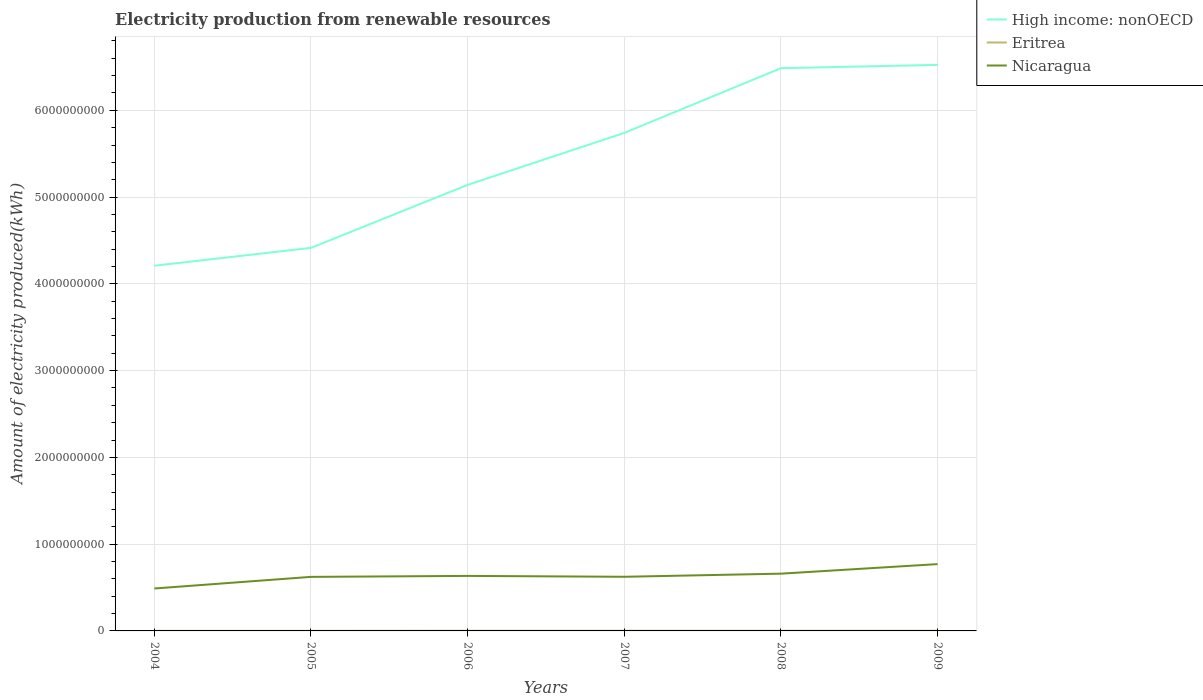How many different coloured lines are there?
Provide a succinct answer. 3. Does the line corresponding to Eritrea intersect with the line corresponding to Nicaragua?
Provide a succinct answer. No. Is the number of lines equal to the number of legend labels?
Your answer should be very brief. Yes. Across all years, what is the maximum amount of electricity produced in Nicaragua?
Offer a terse response. 4.89e+08. In which year was the amount of electricity produced in Eritrea maximum?
Provide a succinct answer. 2004. What is the total amount of electricity produced in Nicaragua in the graph?
Offer a terse response. -3.70e+07. What is the difference between the highest and the second highest amount of electricity produced in Eritrea?
Make the answer very short. 1.00e+06. How many lines are there?
Provide a succinct answer. 3. How many years are there in the graph?
Offer a very short reply. 6. What is the difference between two consecutive major ticks on the Y-axis?
Provide a succinct answer. 1.00e+09. Does the graph contain any zero values?
Make the answer very short. No. How many legend labels are there?
Keep it short and to the point. 3. What is the title of the graph?
Give a very brief answer. Electricity production from renewable resources. Does "Azerbaijan" appear as one of the legend labels in the graph?
Provide a short and direct response. No. What is the label or title of the X-axis?
Your answer should be compact. Years. What is the label or title of the Y-axis?
Ensure brevity in your answer.  Amount of electricity produced(kWh). What is the Amount of electricity produced(kWh) of High income: nonOECD in 2004?
Make the answer very short. 4.21e+09. What is the Amount of electricity produced(kWh) of Nicaragua in 2004?
Give a very brief answer. 4.89e+08. What is the Amount of electricity produced(kWh) of High income: nonOECD in 2005?
Your response must be concise. 4.42e+09. What is the Amount of electricity produced(kWh) of Eritrea in 2005?
Provide a succinct answer. 1.00e+06. What is the Amount of electricity produced(kWh) of Nicaragua in 2005?
Your answer should be very brief. 6.23e+08. What is the Amount of electricity produced(kWh) of High income: nonOECD in 2006?
Keep it short and to the point. 5.14e+09. What is the Amount of electricity produced(kWh) of Eritrea in 2006?
Offer a very short reply. 2.00e+06. What is the Amount of electricity produced(kWh) of Nicaragua in 2006?
Your answer should be compact. 6.34e+08. What is the Amount of electricity produced(kWh) of High income: nonOECD in 2007?
Your answer should be very brief. 5.74e+09. What is the Amount of electricity produced(kWh) of Eritrea in 2007?
Make the answer very short. 2.00e+06. What is the Amount of electricity produced(kWh) of Nicaragua in 2007?
Keep it short and to the point. 6.24e+08. What is the Amount of electricity produced(kWh) in High income: nonOECD in 2008?
Provide a succinct answer. 6.49e+09. What is the Amount of electricity produced(kWh) in Nicaragua in 2008?
Your answer should be very brief. 6.60e+08. What is the Amount of electricity produced(kWh) of High income: nonOECD in 2009?
Offer a very short reply. 6.52e+09. What is the Amount of electricity produced(kWh) of Nicaragua in 2009?
Give a very brief answer. 7.70e+08. Across all years, what is the maximum Amount of electricity produced(kWh) of High income: nonOECD?
Provide a short and direct response. 6.52e+09. Across all years, what is the maximum Amount of electricity produced(kWh) in Eritrea?
Offer a very short reply. 2.00e+06. Across all years, what is the maximum Amount of electricity produced(kWh) of Nicaragua?
Your response must be concise. 7.70e+08. Across all years, what is the minimum Amount of electricity produced(kWh) of High income: nonOECD?
Your answer should be compact. 4.21e+09. Across all years, what is the minimum Amount of electricity produced(kWh) of Eritrea?
Your answer should be very brief. 1.00e+06. Across all years, what is the minimum Amount of electricity produced(kWh) in Nicaragua?
Your answer should be very brief. 4.89e+08. What is the total Amount of electricity produced(kWh) in High income: nonOECD in the graph?
Your answer should be very brief. 3.25e+1. What is the total Amount of electricity produced(kWh) of Nicaragua in the graph?
Keep it short and to the point. 3.80e+09. What is the difference between the Amount of electricity produced(kWh) in High income: nonOECD in 2004 and that in 2005?
Offer a very short reply. -2.06e+08. What is the difference between the Amount of electricity produced(kWh) in Eritrea in 2004 and that in 2005?
Offer a terse response. 0. What is the difference between the Amount of electricity produced(kWh) of Nicaragua in 2004 and that in 2005?
Provide a short and direct response. -1.34e+08. What is the difference between the Amount of electricity produced(kWh) of High income: nonOECD in 2004 and that in 2006?
Make the answer very short. -9.32e+08. What is the difference between the Amount of electricity produced(kWh) in Nicaragua in 2004 and that in 2006?
Provide a succinct answer. -1.45e+08. What is the difference between the Amount of electricity produced(kWh) of High income: nonOECD in 2004 and that in 2007?
Ensure brevity in your answer.  -1.53e+09. What is the difference between the Amount of electricity produced(kWh) of Eritrea in 2004 and that in 2007?
Ensure brevity in your answer.  -1.00e+06. What is the difference between the Amount of electricity produced(kWh) of Nicaragua in 2004 and that in 2007?
Keep it short and to the point. -1.35e+08. What is the difference between the Amount of electricity produced(kWh) in High income: nonOECD in 2004 and that in 2008?
Offer a terse response. -2.28e+09. What is the difference between the Amount of electricity produced(kWh) of Eritrea in 2004 and that in 2008?
Your response must be concise. -1.00e+06. What is the difference between the Amount of electricity produced(kWh) of Nicaragua in 2004 and that in 2008?
Your answer should be very brief. -1.71e+08. What is the difference between the Amount of electricity produced(kWh) of High income: nonOECD in 2004 and that in 2009?
Ensure brevity in your answer.  -2.32e+09. What is the difference between the Amount of electricity produced(kWh) in Nicaragua in 2004 and that in 2009?
Ensure brevity in your answer.  -2.81e+08. What is the difference between the Amount of electricity produced(kWh) in High income: nonOECD in 2005 and that in 2006?
Your answer should be very brief. -7.26e+08. What is the difference between the Amount of electricity produced(kWh) in Eritrea in 2005 and that in 2006?
Keep it short and to the point. -1.00e+06. What is the difference between the Amount of electricity produced(kWh) of Nicaragua in 2005 and that in 2006?
Offer a terse response. -1.10e+07. What is the difference between the Amount of electricity produced(kWh) in High income: nonOECD in 2005 and that in 2007?
Provide a succinct answer. -1.32e+09. What is the difference between the Amount of electricity produced(kWh) of Nicaragua in 2005 and that in 2007?
Give a very brief answer. -1.00e+06. What is the difference between the Amount of electricity produced(kWh) in High income: nonOECD in 2005 and that in 2008?
Offer a very short reply. -2.07e+09. What is the difference between the Amount of electricity produced(kWh) in Nicaragua in 2005 and that in 2008?
Ensure brevity in your answer.  -3.70e+07. What is the difference between the Amount of electricity produced(kWh) of High income: nonOECD in 2005 and that in 2009?
Offer a terse response. -2.11e+09. What is the difference between the Amount of electricity produced(kWh) of Eritrea in 2005 and that in 2009?
Give a very brief answer. -1.00e+06. What is the difference between the Amount of electricity produced(kWh) in Nicaragua in 2005 and that in 2009?
Keep it short and to the point. -1.47e+08. What is the difference between the Amount of electricity produced(kWh) in High income: nonOECD in 2006 and that in 2007?
Ensure brevity in your answer.  -5.99e+08. What is the difference between the Amount of electricity produced(kWh) in High income: nonOECD in 2006 and that in 2008?
Make the answer very short. -1.34e+09. What is the difference between the Amount of electricity produced(kWh) of Eritrea in 2006 and that in 2008?
Offer a very short reply. 0. What is the difference between the Amount of electricity produced(kWh) in Nicaragua in 2006 and that in 2008?
Give a very brief answer. -2.60e+07. What is the difference between the Amount of electricity produced(kWh) in High income: nonOECD in 2006 and that in 2009?
Offer a very short reply. -1.38e+09. What is the difference between the Amount of electricity produced(kWh) of Eritrea in 2006 and that in 2009?
Provide a succinct answer. 0. What is the difference between the Amount of electricity produced(kWh) of Nicaragua in 2006 and that in 2009?
Your response must be concise. -1.36e+08. What is the difference between the Amount of electricity produced(kWh) of High income: nonOECD in 2007 and that in 2008?
Your answer should be compact. -7.46e+08. What is the difference between the Amount of electricity produced(kWh) of Eritrea in 2007 and that in 2008?
Your answer should be very brief. 0. What is the difference between the Amount of electricity produced(kWh) of Nicaragua in 2007 and that in 2008?
Your response must be concise. -3.60e+07. What is the difference between the Amount of electricity produced(kWh) of High income: nonOECD in 2007 and that in 2009?
Your answer should be compact. -7.84e+08. What is the difference between the Amount of electricity produced(kWh) of Eritrea in 2007 and that in 2009?
Your response must be concise. 0. What is the difference between the Amount of electricity produced(kWh) in Nicaragua in 2007 and that in 2009?
Your answer should be compact. -1.46e+08. What is the difference between the Amount of electricity produced(kWh) in High income: nonOECD in 2008 and that in 2009?
Offer a terse response. -3.80e+07. What is the difference between the Amount of electricity produced(kWh) in Nicaragua in 2008 and that in 2009?
Offer a terse response. -1.10e+08. What is the difference between the Amount of electricity produced(kWh) of High income: nonOECD in 2004 and the Amount of electricity produced(kWh) of Eritrea in 2005?
Keep it short and to the point. 4.21e+09. What is the difference between the Amount of electricity produced(kWh) of High income: nonOECD in 2004 and the Amount of electricity produced(kWh) of Nicaragua in 2005?
Make the answer very short. 3.59e+09. What is the difference between the Amount of electricity produced(kWh) in Eritrea in 2004 and the Amount of electricity produced(kWh) in Nicaragua in 2005?
Offer a terse response. -6.22e+08. What is the difference between the Amount of electricity produced(kWh) of High income: nonOECD in 2004 and the Amount of electricity produced(kWh) of Eritrea in 2006?
Your response must be concise. 4.21e+09. What is the difference between the Amount of electricity produced(kWh) in High income: nonOECD in 2004 and the Amount of electricity produced(kWh) in Nicaragua in 2006?
Offer a very short reply. 3.58e+09. What is the difference between the Amount of electricity produced(kWh) of Eritrea in 2004 and the Amount of electricity produced(kWh) of Nicaragua in 2006?
Offer a terse response. -6.33e+08. What is the difference between the Amount of electricity produced(kWh) in High income: nonOECD in 2004 and the Amount of electricity produced(kWh) in Eritrea in 2007?
Provide a succinct answer. 4.21e+09. What is the difference between the Amount of electricity produced(kWh) of High income: nonOECD in 2004 and the Amount of electricity produced(kWh) of Nicaragua in 2007?
Make the answer very short. 3.58e+09. What is the difference between the Amount of electricity produced(kWh) of Eritrea in 2004 and the Amount of electricity produced(kWh) of Nicaragua in 2007?
Your answer should be compact. -6.23e+08. What is the difference between the Amount of electricity produced(kWh) in High income: nonOECD in 2004 and the Amount of electricity produced(kWh) in Eritrea in 2008?
Make the answer very short. 4.21e+09. What is the difference between the Amount of electricity produced(kWh) of High income: nonOECD in 2004 and the Amount of electricity produced(kWh) of Nicaragua in 2008?
Offer a terse response. 3.55e+09. What is the difference between the Amount of electricity produced(kWh) in Eritrea in 2004 and the Amount of electricity produced(kWh) in Nicaragua in 2008?
Provide a short and direct response. -6.59e+08. What is the difference between the Amount of electricity produced(kWh) of High income: nonOECD in 2004 and the Amount of electricity produced(kWh) of Eritrea in 2009?
Provide a short and direct response. 4.21e+09. What is the difference between the Amount of electricity produced(kWh) of High income: nonOECD in 2004 and the Amount of electricity produced(kWh) of Nicaragua in 2009?
Your answer should be compact. 3.44e+09. What is the difference between the Amount of electricity produced(kWh) of Eritrea in 2004 and the Amount of electricity produced(kWh) of Nicaragua in 2009?
Your answer should be compact. -7.69e+08. What is the difference between the Amount of electricity produced(kWh) of High income: nonOECD in 2005 and the Amount of electricity produced(kWh) of Eritrea in 2006?
Your response must be concise. 4.41e+09. What is the difference between the Amount of electricity produced(kWh) in High income: nonOECD in 2005 and the Amount of electricity produced(kWh) in Nicaragua in 2006?
Your answer should be very brief. 3.78e+09. What is the difference between the Amount of electricity produced(kWh) of Eritrea in 2005 and the Amount of electricity produced(kWh) of Nicaragua in 2006?
Offer a very short reply. -6.33e+08. What is the difference between the Amount of electricity produced(kWh) in High income: nonOECD in 2005 and the Amount of electricity produced(kWh) in Eritrea in 2007?
Your answer should be compact. 4.41e+09. What is the difference between the Amount of electricity produced(kWh) of High income: nonOECD in 2005 and the Amount of electricity produced(kWh) of Nicaragua in 2007?
Your answer should be compact. 3.79e+09. What is the difference between the Amount of electricity produced(kWh) of Eritrea in 2005 and the Amount of electricity produced(kWh) of Nicaragua in 2007?
Ensure brevity in your answer.  -6.23e+08. What is the difference between the Amount of electricity produced(kWh) in High income: nonOECD in 2005 and the Amount of electricity produced(kWh) in Eritrea in 2008?
Provide a succinct answer. 4.41e+09. What is the difference between the Amount of electricity produced(kWh) in High income: nonOECD in 2005 and the Amount of electricity produced(kWh) in Nicaragua in 2008?
Provide a succinct answer. 3.76e+09. What is the difference between the Amount of electricity produced(kWh) of Eritrea in 2005 and the Amount of electricity produced(kWh) of Nicaragua in 2008?
Your response must be concise. -6.59e+08. What is the difference between the Amount of electricity produced(kWh) in High income: nonOECD in 2005 and the Amount of electricity produced(kWh) in Eritrea in 2009?
Your response must be concise. 4.41e+09. What is the difference between the Amount of electricity produced(kWh) of High income: nonOECD in 2005 and the Amount of electricity produced(kWh) of Nicaragua in 2009?
Keep it short and to the point. 3.64e+09. What is the difference between the Amount of electricity produced(kWh) in Eritrea in 2005 and the Amount of electricity produced(kWh) in Nicaragua in 2009?
Give a very brief answer. -7.69e+08. What is the difference between the Amount of electricity produced(kWh) of High income: nonOECD in 2006 and the Amount of electricity produced(kWh) of Eritrea in 2007?
Ensure brevity in your answer.  5.14e+09. What is the difference between the Amount of electricity produced(kWh) in High income: nonOECD in 2006 and the Amount of electricity produced(kWh) in Nicaragua in 2007?
Your answer should be very brief. 4.52e+09. What is the difference between the Amount of electricity produced(kWh) in Eritrea in 2006 and the Amount of electricity produced(kWh) in Nicaragua in 2007?
Make the answer very short. -6.22e+08. What is the difference between the Amount of electricity produced(kWh) in High income: nonOECD in 2006 and the Amount of electricity produced(kWh) in Eritrea in 2008?
Your response must be concise. 5.14e+09. What is the difference between the Amount of electricity produced(kWh) of High income: nonOECD in 2006 and the Amount of electricity produced(kWh) of Nicaragua in 2008?
Offer a terse response. 4.48e+09. What is the difference between the Amount of electricity produced(kWh) in Eritrea in 2006 and the Amount of electricity produced(kWh) in Nicaragua in 2008?
Offer a very short reply. -6.58e+08. What is the difference between the Amount of electricity produced(kWh) in High income: nonOECD in 2006 and the Amount of electricity produced(kWh) in Eritrea in 2009?
Ensure brevity in your answer.  5.14e+09. What is the difference between the Amount of electricity produced(kWh) in High income: nonOECD in 2006 and the Amount of electricity produced(kWh) in Nicaragua in 2009?
Offer a terse response. 4.37e+09. What is the difference between the Amount of electricity produced(kWh) of Eritrea in 2006 and the Amount of electricity produced(kWh) of Nicaragua in 2009?
Offer a terse response. -7.68e+08. What is the difference between the Amount of electricity produced(kWh) in High income: nonOECD in 2007 and the Amount of electricity produced(kWh) in Eritrea in 2008?
Give a very brief answer. 5.74e+09. What is the difference between the Amount of electricity produced(kWh) in High income: nonOECD in 2007 and the Amount of electricity produced(kWh) in Nicaragua in 2008?
Your answer should be compact. 5.08e+09. What is the difference between the Amount of electricity produced(kWh) in Eritrea in 2007 and the Amount of electricity produced(kWh) in Nicaragua in 2008?
Make the answer very short. -6.58e+08. What is the difference between the Amount of electricity produced(kWh) of High income: nonOECD in 2007 and the Amount of electricity produced(kWh) of Eritrea in 2009?
Offer a very short reply. 5.74e+09. What is the difference between the Amount of electricity produced(kWh) of High income: nonOECD in 2007 and the Amount of electricity produced(kWh) of Nicaragua in 2009?
Provide a succinct answer. 4.97e+09. What is the difference between the Amount of electricity produced(kWh) of Eritrea in 2007 and the Amount of electricity produced(kWh) of Nicaragua in 2009?
Offer a very short reply. -7.68e+08. What is the difference between the Amount of electricity produced(kWh) of High income: nonOECD in 2008 and the Amount of electricity produced(kWh) of Eritrea in 2009?
Make the answer very short. 6.48e+09. What is the difference between the Amount of electricity produced(kWh) of High income: nonOECD in 2008 and the Amount of electricity produced(kWh) of Nicaragua in 2009?
Provide a succinct answer. 5.72e+09. What is the difference between the Amount of electricity produced(kWh) of Eritrea in 2008 and the Amount of electricity produced(kWh) of Nicaragua in 2009?
Your answer should be very brief. -7.68e+08. What is the average Amount of electricity produced(kWh) in High income: nonOECD per year?
Offer a terse response. 5.42e+09. What is the average Amount of electricity produced(kWh) of Eritrea per year?
Make the answer very short. 1.67e+06. What is the average Amount of electricity produced(kWh) in Nicaragua per year?
Give a very brief answer. 6.33e+08. In the year 2004, what is the difference between the Amount of electricity produced(kWh) of High income: nonOECD and Amount of electricity produced(kWh) of Eritrea?
Offer a terse response. 4.21e+09. In the year 2004, what is the difference between the Amount of electricity produced(kWh) in High income: nonOECD and Amount of electricity produced(kWh) in Nicaragua?
Provide a succinct answer. 3.72e+09. In the year 2004, what is the difference between the Amount of electricity produced(kWh) of Eritrea and Amount of electricity produced(kWh) of Nicaragua?
Give a very brief answer. -4.88e+08. In the year 2005, what is the difference between the Amount of electricity produced(kWh) of High income: nonOECD and Amount of electricity produced(kWh) of Eritrea?
Ensure brevity in your answer.  4.41e+09. In the year 2005, what is the difference between the Amount of electricity produced(kWh) in High income: nonOECD and Amount of electricity produced(kWh) in Nicaragua?
Ensure brevity in your answer.  3.79e+09. In the year 2005, what is the difference between the Amount of electricity produced(kWh) in Eritrea and Amount of electricity produced(kWh) in Nicaragua?
Your answer should be compact. -6.22e+08. In the year 2006, what is the difference between the Amount of electricity produced(kWh) of High income: nonOECD and Amount of electricity produced(kWh) of Eritrea?
Provide a succinct answer. 5.14e+09. In the year 2006, what is the difference between the Amount of electricity produced(kWh) of High income: nonOECD and Amount of electricity produced(kWh) of Nicaragua?
Provide a succinct answer. 4.51e+09. In the year 2006, what is the difference between the Amount of electricity produced(kWh) in Eritrea and Amount of electricity produced(kWh) in Nicaragua?
Provide a short and direct response. -6.32e+08. In the year 2007, what is the difference between the Amount of electricity produced(kWh) in High income: nonOECD and Amount of electricity produced(kWh) in Eritrea?
Your answer should be compact. 5.74e+09. In the year 2007, what is the difference between the Amount of electricity produced(kWh) of High income: nonOECD and Amount of electricity produced(kWh) of Nicaragua?
Provide a succinct answer. 5.12e+09. In the year 2007, what is the difference between the Amount of electricity produced(kWh) in Eritrea and Amount of electricity produced(kWh) in Nicaragua?
Provide a short and direct response. -6.22e+08. In the year 2008, what is the difference between the Amount of electricity produced(kWh) of High income: nonOECD and Amount of electricity produced(kWh) of Eritrea?
Offer a very short reply. 6.48e+09. In the year 2008, what is the difference between the Amount of electricity produced(kWh) of High income: nonOECD and Amount of electricity produced(kWh) of Nicaragua?
Offer a terse response. 5.83e+09. In the year 2008, what is the difference between the Amount of electricity produced(kWh) of Eritrea and Amount of electricity produced(kWh) of Nicaragua?
Make the answer very short. -6.58e+08. In the year 2009, what is the difference between the Amount of electricity produced(kWh) of High income: nonOECD and Amount of electricity produced(kWh) of Eritrea?
Your response must be concise. 6.52e+09. In the year 2009, what is the difference between the Amount of electricity produced(kWh) in High income: nonOECD and Amount of electricity produced(kWh) in Nicaragua?
Your answer should be compact. 5.75e+09. In the year 2009, what is the difference between the Amount of electricity produced(kWh) of Eritrea and Amount of electricity produced(kWh) of Nicaragua?
Your response must be concise. -7.68e+08. What is the ratio of the Amount of electricity produced(kWh) of High income: nonOECD in 2004 to that in 2005?
Provide a short and direct response. 0.95. What is the ratio of the Amount of electricity produced(kWh) in Nicaragua in 2004 to that in 2005?
Make the answer very short. 0.78. What is the ratio of the Amount of electricity produced(kWh) of High income: nonOECD in 2004 to that in 2006?
Ensure brevity in your answer.  0.82. What is the ratio of the Amount of electricity produced(kWh) of Eritrea in 2004 to that in 2006?
Provide a succinct answer. 0.5. What is the ratio of the Amount of electricity produced(kWh) in Nicaragua in 2004 to that in 2006?
Your answer should be compact. 0.77. What is the ratio of the Amount of electricity produced(kWh) of High income: nonOECD in 2004 to that in 2007?
Your answer should be compact. 0.73. What is the ratio of the Amount of electricity produced(kWh) of Nicaragua in 2004 to that in 2007?
Provide a short and direct response. 0.78. What is the ratio of the Amount of electricity produced(kWh) in High income: nonOECD in 2004 to that in 2008?
Provide a succinct answer. 0.65. What is the ratio of the Amount of electricity produced(kWh) of Nicaragua in 2004 to that in 2008?
Provide a short and direct response. 0.74. What is the ratio of the Amount of electricity produced(kWh) in High income: nonOECD in 2004 to that in 2009?
Your response must be concise. 0.65. What is the ratio of the Amount of electricity produced(kWh) in Eritrea in 2004 to that in 2009?
Make the answer very short. 0.5. What is the ratio of the Amount of electricity produced(kWh) of Nicaragua in 2004 to that in 2009?
Offer a very short reply. 0.64. What is the ratio of the Amount of electricity produced(kWh) of High income: nonOECD in 2005 to that in 2006?
Offer a terse response. 0.86. What is the ratio of the Amount of electricity produced(kWh) in Eritrea in 2005 to that in 2006?
Offer a very short reply. 0.5. What is the ratio of the Amount of electricity produced(kWh) of Nicaragua in 2005 to that in 2006?
Your answer should be compact. 0.98. What is the ratio of the Amount of electricity produced(kWh) of High income: nonOECD in 2005 to that in 2007?
Offer a terse response. 0.77. What is the ratio of the Amount of electricity produced(kWh) in Eritrea in 2005 to that in 2007?
Your answer should be compact. 0.5. What is the ratio of the Amount of electricity produced(kWh) in High income: nonOECD in 2005 to that in 2008?
Provide a short and direct response. 0.68. What is the ratio of the Amount of electricity produced(kWh) in Nicaragua in 2005 to that in 2008?
Provide a succinct answer. 0.94. What is the ratio of the Amount of electricity produced(kWh) of High income: nonOECD in 2005 to that in 2009?
Your answer should be very brief. 0.68. What is the ratio of the Amount of electricity produced(kWh) of Eritrea in 2005 to that in 2009?
Your answer should be compact. 0.5. What is the ratio of the Amount of electricity produced(kWh) of Nicaragua in 2005 to that in 2009?
Give a very brief answer. 0.81. What is the ratio of the Amount of electricity produced(kWh) of High income: nonOECD in 2006 to that in 2007?
Your response must be concise. 0.9. What is the ratio of the Amount of electricity produced(kWh) of High income: nonOECD in 2006 to that in 2008?
Provide a succinct answer. 0.79. What is the ratio of the Amount of electricity produced(kWh) in Eritrea in 2006 to that in 2008?
Your answer should be compact. 1. What is the ratio of the Amount of electricity produced(kWh) of Nicaragua in 2006 to that in 2008?
Give a very brief answer. 0.96. What is the ratio of the Amount of electricity produced(kWh) of High income: nonOECD in 2006 to that in 2009?
Provide a succinct answer. 0.79. What is the ratio of the Amount of electricity produced(kWh) in Eritrea in 2006 to that in 2009?
Give a very brief answer. 1. What is the ratio of the Amount of electricity produced(kWh) of Nicaragua in 2006 to that in 2009?
Provide a succinct answer. 0.82. What is the ratio of the Amount of electricity produced(kWh) in High income: nonOECD in 2007 to that in 2008?
Provide a succinct answer. 0.89. What is the ratio of the Amount of electricity produced(kWh) of Eritrea in 2007 to that in 2008?
Your answer should be compact. 1. What is the ratio of the Amount of electricity produced(kWh) in Nicaragua in 2007 to that in 2008?
Ensure brevity in your answer.  0.95. What is the ratio of the Amount of electricity produced(kWh) in High income: nonOECD in 2007 to that in 2009?
Your response must be concise. 0.88. What is the ratio of the Amount of electricity produced(kWh) of Eritrea in 2007 to that in 2009?
Provide a short and direct response. 1. What is the ratio of the Amount of electricity produced(kWh) of Nicaragua in 2007 to that in 2009?
Offer a very short reply. 0.81. What is the ratio of the Amount of electricity produced(kWh) in High income: nonOECD in 2008 to that in 2009?
Your answer should be very brief. 0.99. What is the ratio of the Amount of electricity produced(kWh) of Eritrea in 2008 to that in 2009?
Keep it short and to the point. 1. What is the difference between the highest and the second highest Amount of electricity produced(kWh) in High income: nonOECD?
Provide a succinct answer. 3.80e+07. What is the difference between the highest and the second highest Amount of electricity produced(kWh) of Eritrea?
Your answer should be very brief. 0. What is the difference between the highest and the second highest Amount of electricity produced(kWh) in Nicaragua?
Your response must be concise. 1.10e+08. What is the difference between the highest and the lowest Amount of electricity produced(kWh) of High income: nonOECD?
Keep it short and to the point. 2.32e+09. What is the difference between the highest and the lowest Amount of electricity produced(kWh) of Nicaragua?
Offer a terse response. 2.81e+08. 